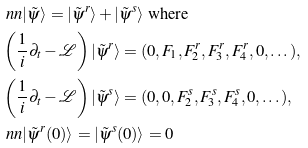Convert formula to latex. <formula><loc_0><loc_0><loc_500><loc_500>& \ n n | \tilde { \psi } \rangle = | \tilde { \psi } ^ { r } \rangle + | \tilde { \psi } ^ { s } \rangle \text { where } \\ & \left ( \frac { 1 } { i } \partial _ { t } - \mathcal { L } \right ) | \tilde { \psi } ^ { r } \rangle = ( 0 , F _ { 1 } , F _ { 2 } ^ { r } , F _ { 3 } ^ { r } , F _ { 4 } ^ { r } , 0 , \dots ) , \\ & \left ( \frac { 1 } { i } \partial _ { t } - \mathcal { L } \right ) | \tilde { \psi } ^ { s } \rangle = ( 0 , 0 , F _ { 2 } ^ { s } , F _ { 3 } ^ { s } , F _ { 4 } ^ { s } , 0 , \dots ) , \\ & \ n n | \tilde { \psi } ^ { r } ( 0 ) \rangle = | \tilde { \psi } ^ { s } ( 0 ) \rangle = 0</formula> 